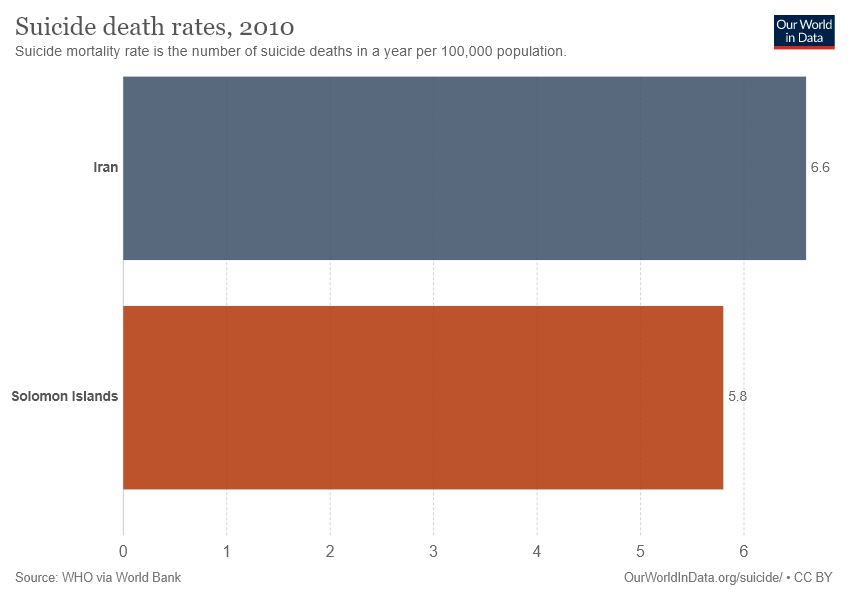Give some essential details in this illustration. Iran data is 6.6.. The ratio between the two data is approximately 1.137931... 